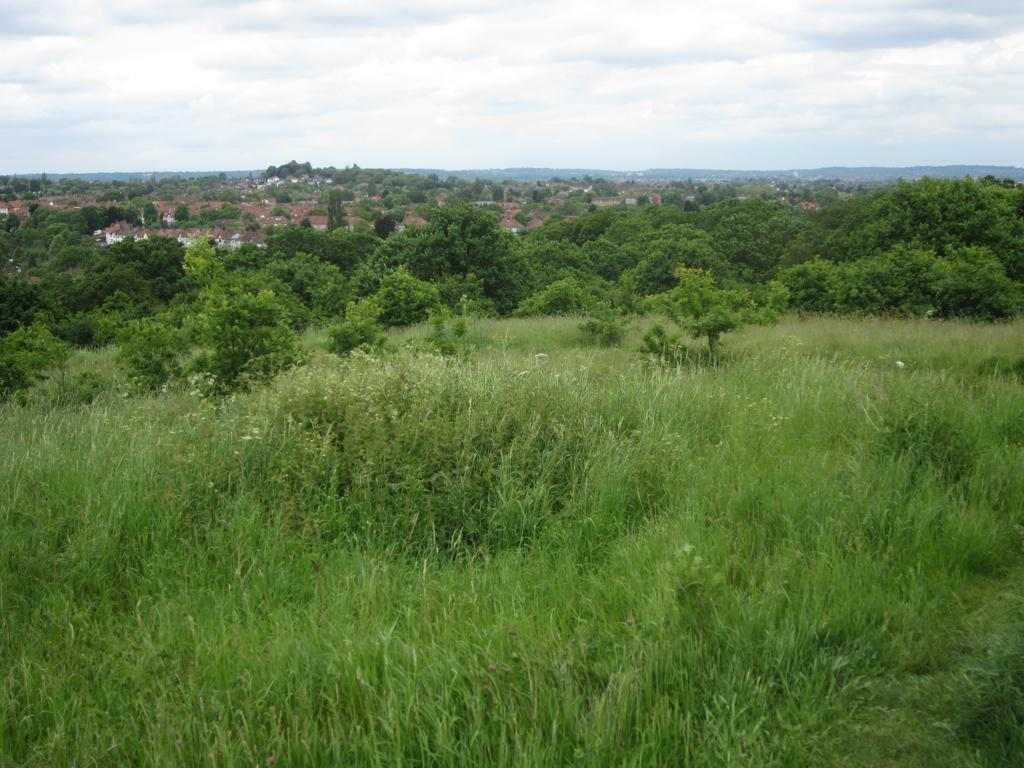What type of vegetation can be seen in the image? There is grass in the image. What other natural elements are present in the image? There are trees in the image. What type of structures can be seen in the image? There are houses in the image. What is visible in the background of the image? The sky is visible in the background of the image. What can be observed in the sky? There are clouds in the sky. Can you see any feathers floating in the sky in the image? There are no feathers visible in the image; only clouds can be seen in the sky. What type of bone is present in the image? There is no bone present in the image. 